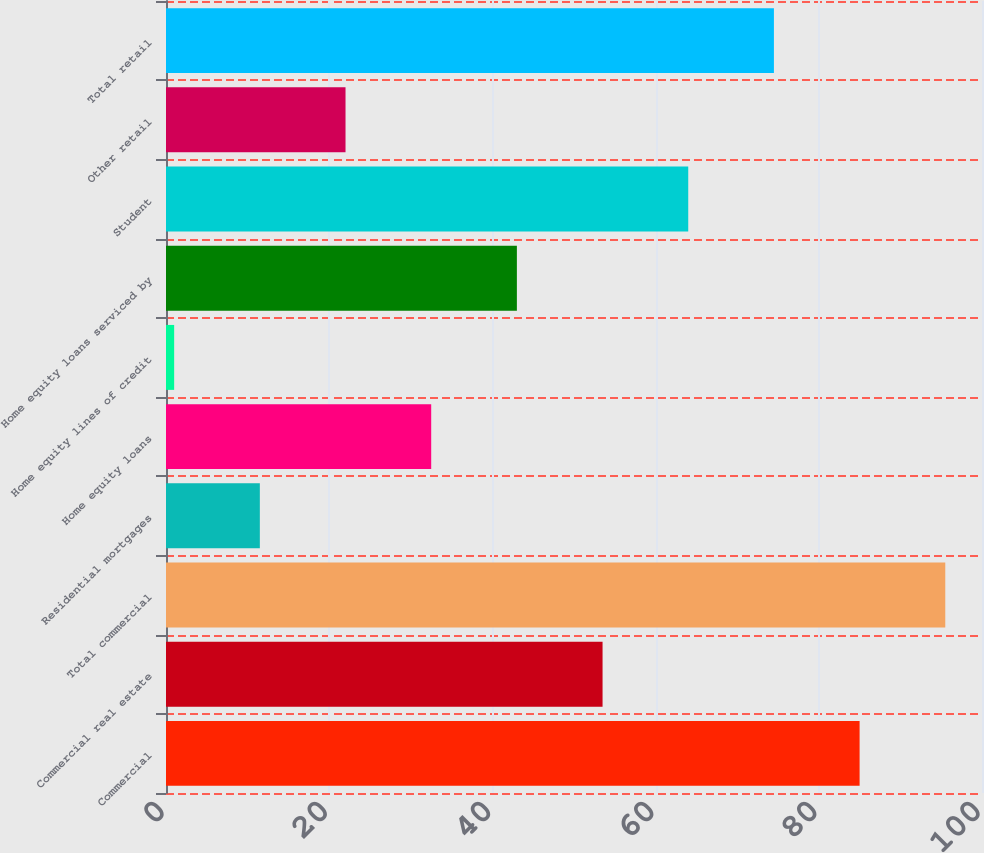Convert chart. <chart><loc_0><loc_0><loc_500><loc_500><bar_chart><fcel>Commercial<fcel>Commercial real estate<fcel>Total commercial<fcel>Residential mortgages<fcel>Home equity loans<fcel>Home equity lines of credit<fcel>Home equity loans serviced by<fcel>Student<fcel>Other retail<fcel>Total retail<nl><fcel>85<fcel>53.5<fcel>95.5<fcel>11.5<fcel>32.5<fcel>1<fcel>43<fcel>64<fcel>22<fcel>74.5<nl></chart> 